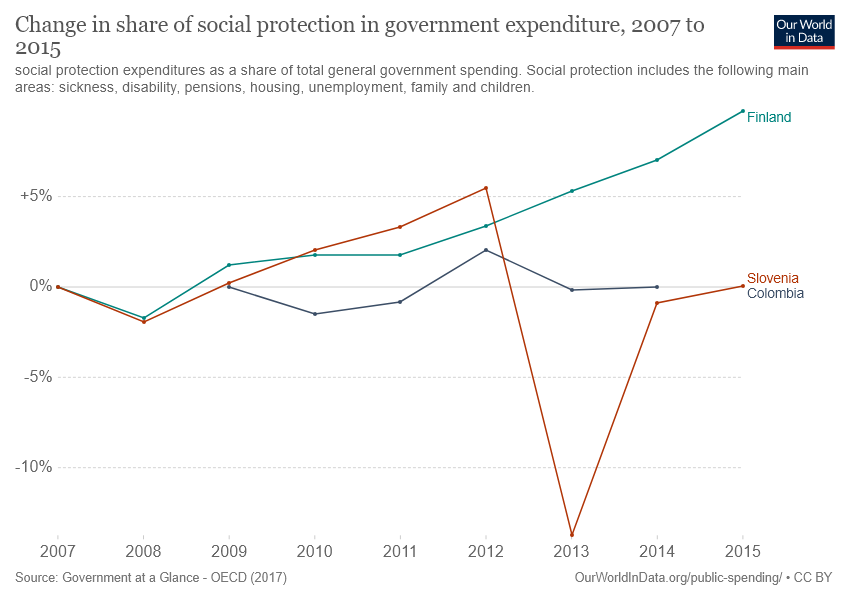Point out several critical features in this image. The bar that displays the lowest value of social protection in government expenditure in the year 2013 is Slovenia. In 2013, the orange bar did not intersect any lines. 